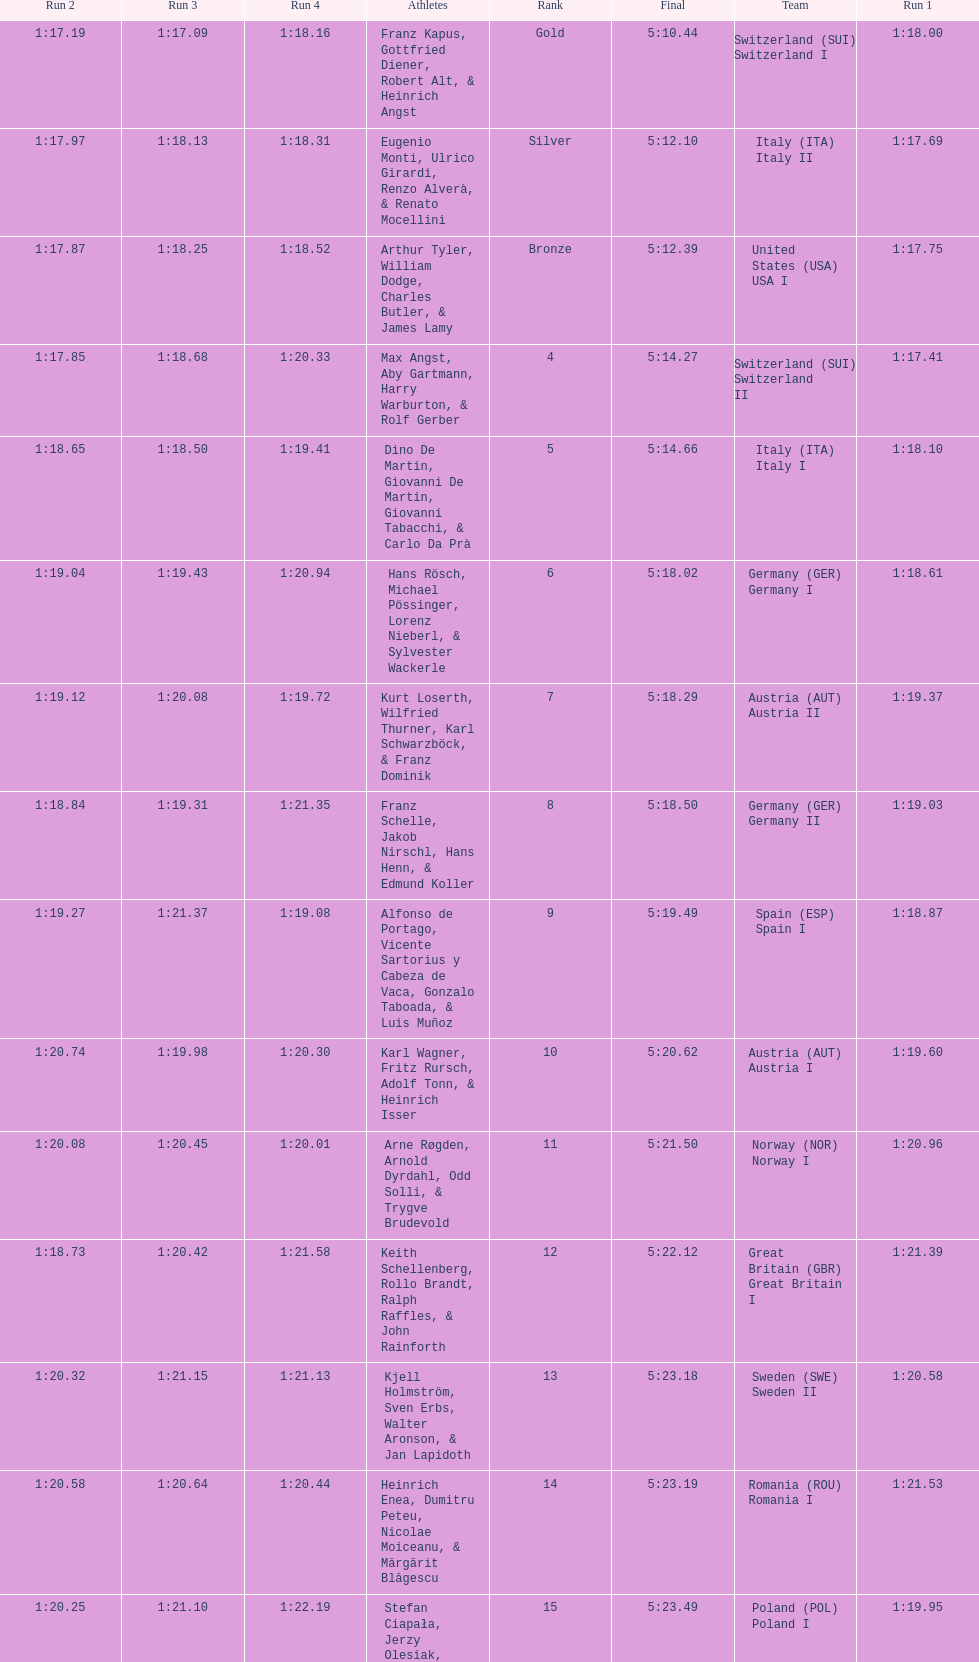Parse the table in full. {'header': ['Run 2', 'Run 3', 'Run 4', 'Athletes', 'Rank', 'Final', 'Team', 'Run 1'], 'rows': [['1:17.19', '1:17.09', '1:18.16', 'Franz Kapus, Gottfried Diener, Robert Alt, & Heinrich Angst', 'Gold', '5:10.44', 'Switzerland\xa0(SUI) Switzerland I', '1:18.00'], ['1:17.97', '1:18.13', '1:18.31', 'Eugenio Monti, Ulrico Girardi, Renzo Alverà, & Renato Mocellini', 'Silver', '5:12.10', 'Italy\xa0(ITA) Italy II', '1:17.69'], ['1:17.87', '1:18.25', '1:18.52', 'Arthur Tyler, William Dodge, Charles Butler, & James Lamy', 'Bronze', '5:12.39', 'United States\xa0(USA) USA I', '1:17.75'], ['1:17.85', '1:18.68', '1:20.33', 'Max Angst, Aby Gartmann, Harry Warburton, & Rolf Gerber', '4', '5:14.27', 'Switzerland\xa0(SUI) Switzerland II', '1:17.41'], ['1:18.65', '1:18.50', '1:19.41', 'Dino De Martin, Giovanni De Martin, Giovanni Tabacchi, & Carlo Da Prà', '5', '5:14.66', 'Italy\xa0(ITA) Italy I', '1:18.10'], ['1:19.04', '1:19.43', '1:20.94', 'Hans Rösch, Michael Pössinger, Lorenz Nieberl, & Sylvester Wackerle', '6', '5:18.02', 'Germany\xa0(GER) Germany I', '1:18.61'], ['1:19.12', '1:20.08', '1:19.72', 'Kurt Loserth, Wilfried Thurner, Karl Schwarzböck, & Franz Dominik', '7', '5:18.29', 'Austria\xa0(AUT) Austria II', '1:19.37'], ['1:18.84', '1:19.31', '1:21.35', 'Franz Schelle, Jakob Nirschl, Hans Henn, & Edmund Koller', '8', '5:18.50', 'Germany\xa0(GER) Germany II', '1:19.03'], ['1:19.27', '1:21.37', '1:19.08', 'Alfonso de Portago, Vicente Sartorius y Cabeza de Vaca, Gonzalo Taboada, & Luis Muñoz', '9', '5:19.49', 'Spain\xa0(ESP) Spain I', '1:18.87'], ['1:20.74', '1:19.98', '1:20.30', 'Karl Wagner, Fritz Rursch, Adolf Tonn, & Heinrich Isser', '10', '5:20.62', 'Austria\xa0(AUT) Austria I', '1:19.60'], ['1:20.08', '1:20.45', '1:20.01', 'Arne Røgden, Arnold Dyrdahl, Odd Solli, & Trygve Brudevold', '11', '5:21.50', 'Norway\xa0(NOR) Norway I', '1:20.96'], ['1:18.73', '1:20.42', '1:21.58', 'Keith Schellenberg, Rollo Brandt, Ralph Raffles, & John Rainforth', '12', '5:22.12', 'Great Britain\xa0(GBR) Great Britain I', '1:21.39'], ['1:20.32', '1:21.15', '1:21.13', 'Kjell Holmström, Sven Erbs, Walter Aronson, & Jan Lapidoth', '13', '5:23.18', 'Sweden\xa0(SWE) Sweden II', '1:20.58'], ['1:20.58', '1:20.64', '1:20.44', 'Heinrich Enea, Dumitru Peteu, Nicolae Moiceanu, & Mărgărit Blăgescu', '14', '5:23.19', 'Romania\xa0(ROU) Romania I', '1:21.53'], ['1:20.25', '1:21.10', '1:22.19', 'Stefan Ciapała, Jerzy Olesiak, Józef Szymański, & Aleksander Habala', '15', '5:23.49', 'Poland\xa0(POL) Poland I', '1:19.95'], ['1:19.98', '1:22.75', '1:21.86', 'Olle Axelsson, Ebbe Wallén, Sune Skagerling, & Gunnar Åhs', '16', '5:23.54', 'Sweden\xa0(SWE) Sweden I', '1:18.95'], ['1:19.92', '1:22.51', '1:20.58', 'Stuart Parkinson, John Read, Christopher Williams, & Rodney Mann', '17', '5:23.73', 'Great Britain\xa0(GBR) Great Britain II', '1:20.72'], ['1:21.25', '1:20.95', '1:21.63', 'André Robin, Pierre Bouvier, Jacques Panciroli, & Lucien Grosso', '18', '5:23.83', 'France\xa0(FRA) France I', '1:20.00'], ['1:22.47', '1:21.22', '1:20.50', 'James Bickford, Donald Jacques, Lawrence McKillip, & Hubert Miller', '19', '5:25.16', 'United States\xa0(USA) USA II', '1:20.97'], ['1:21.22', '1:22.37', '1:23.03', 'Constantin Dragomir, Vasile Panait, Ion Staicu, & Gheorghe Moldoveanu', '20', '5:27.83', 'Romania\xa0(ROU) Romania II', '1:21.21'], ['', '', '', 'Aleksy Konieczny, Zygmunt Konieczny, Włodzimierz Źróbik, & Zbigniew Skowroński/Jan Dąbrowski(*)', '21', '5:28.40', 'Poland\xa0(POL) Poland II', '']]} How many teams did germany have? 2. 